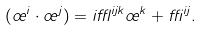<formula> <loc_0><loc_0><loc_500><loc_500>( \sigma ^ { i } \cdot \sigma ^ { j } ) = i \epsilon ^ { i j k } \sigma ^ { k } + \delta ^ { i j } .</formula> 